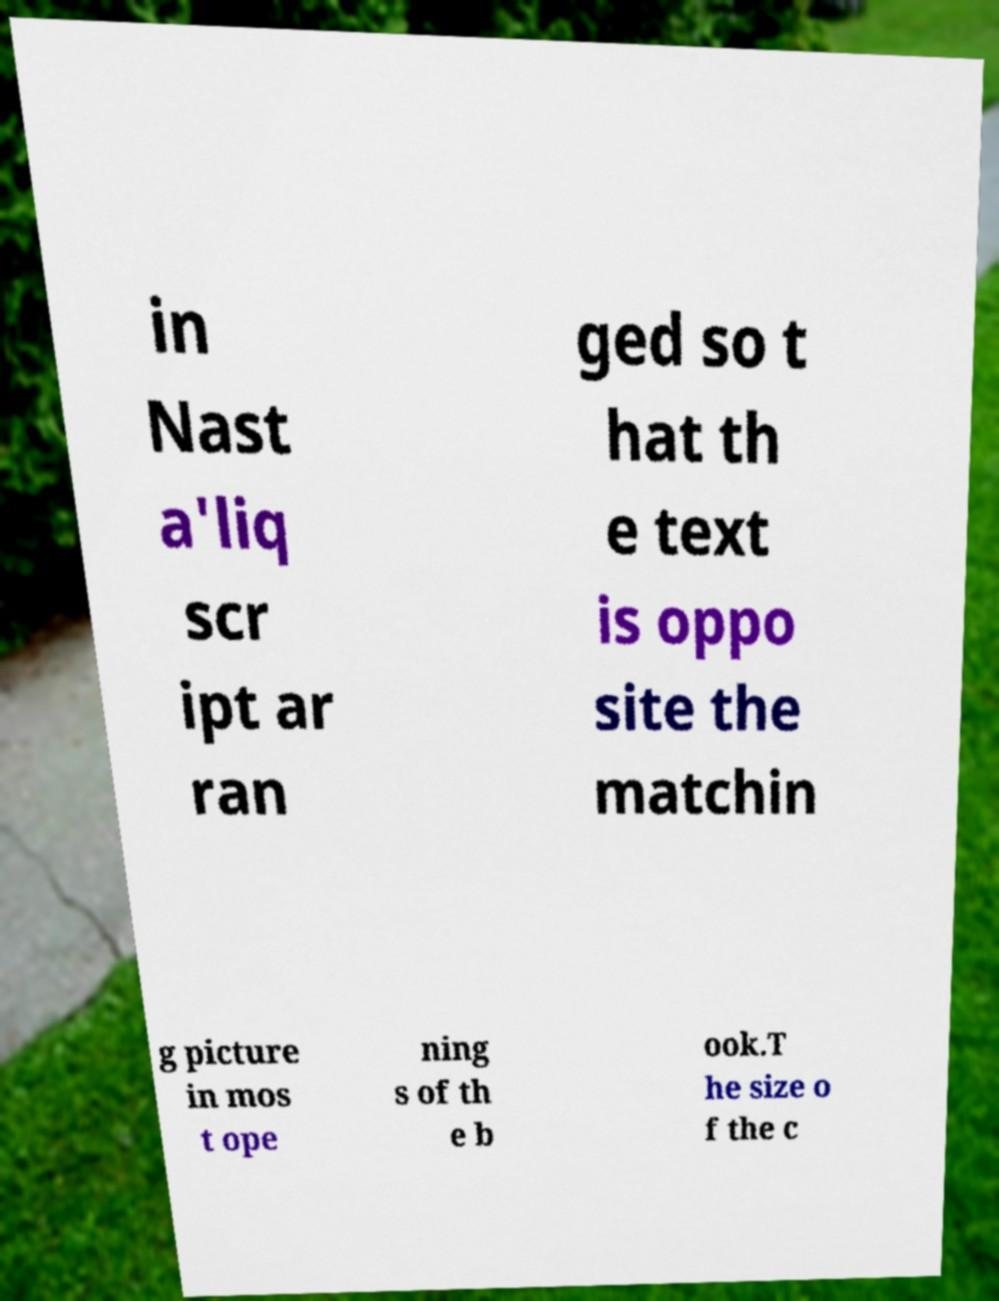Please read and relay the text visible in this image. What does it say? in Nast a'liq scr ipt ar ran ged so t hat th e text is oppo site the matchin g picture in mos t ope ning s of th e b ook.T he size o f the c 